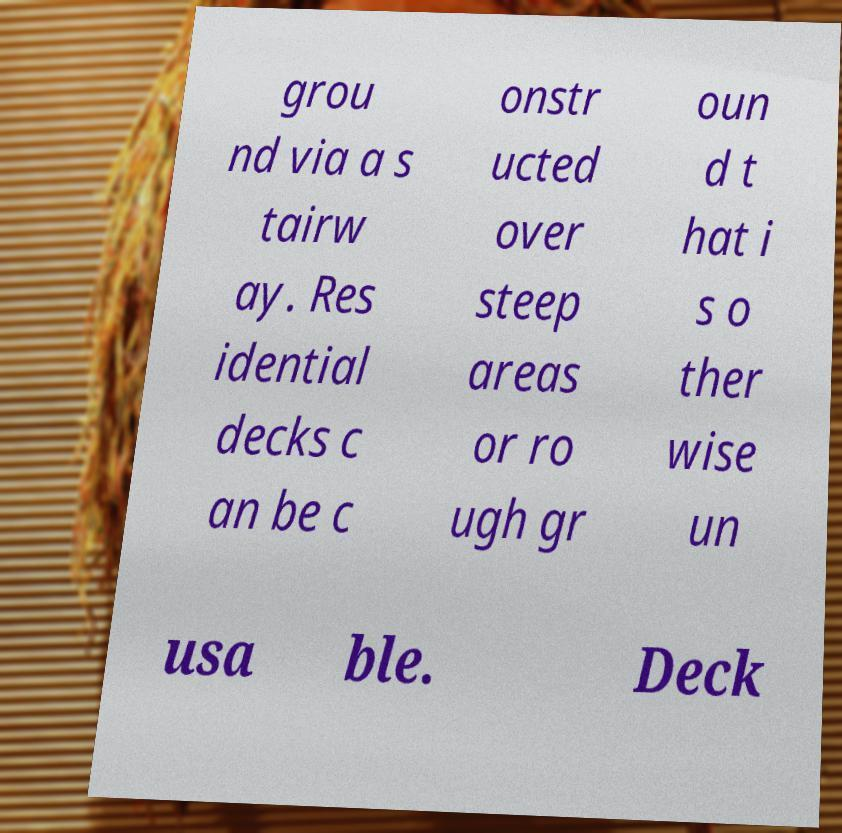Can you accurately transcribe the text from the provided image for me? grou nd via a s tairw ay. Res idential decks c an be c onstr ucted over steep areas or ro ugh gr oun d t hat i s o ther wise un usa ble. Deck 